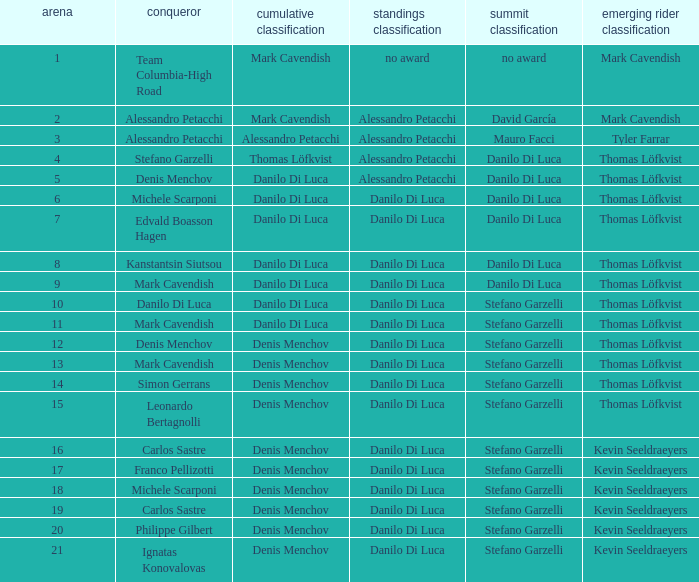When thomas löfkvist is the  young rider classification and alessandro petacchi is the points classification who are the general classifications?  Thomas Löfkvist, Danilo Di Luca. 